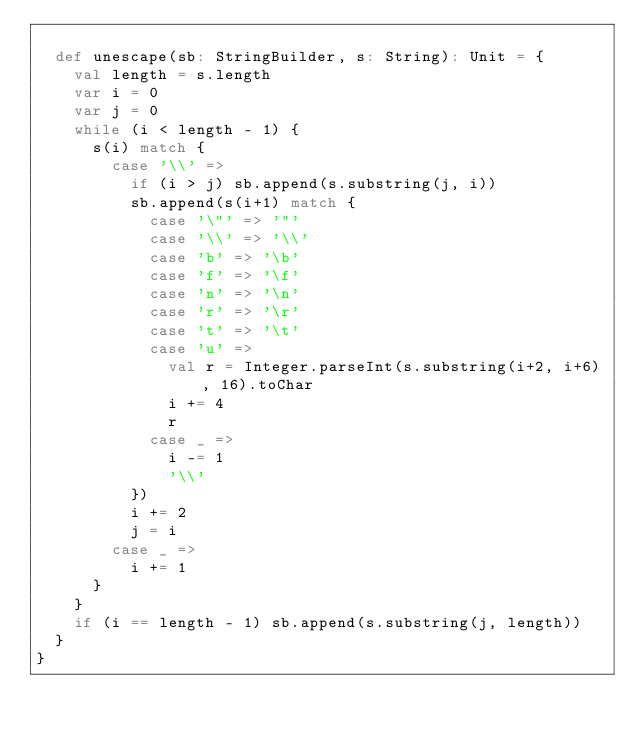<code> <loc_0><loc_0><loc_500><loc_500><_Scala_>
  def unescape(sb: StringBuilder, s: String): Unit = {
    val length = s.length
    var i = 0
    var j = 0
    while (i < length - 1) {
      s(i) match {
        case '\\' =>
          if (i > j) sb.append(s.substring(j, i))
          sb.append(s(i+1) match {
            case '\"' => '"'
            case '\\' => '\\'
            case 'b' => '\b'
            case 'f' => '\f'
            case 'n' => '\n'
            case 'r' => '\r'
            case 't' => '\t'
            case 'u' =>
              val r = Integer.parseInt(s.substring(i+2, i+6), 16).toChar
              i += 4
              r
            case _ =>
              i -= 1
              '\\'
          })
          i += 2
          j = i
        case _ =>
          i += 1
      }
    }
    if (i == length - 1) sb.append(s.substring(j, length))
  }
}
</code> 